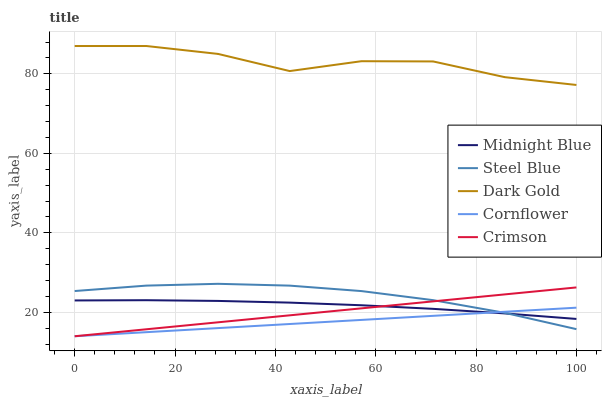Does Cornflower have the minimum area under the curve?
Answer yes or no. Yes. Does Dark Gold have the maximum area under the curve?
Answer yes or no. Yes. Does Dark Gold have the minimum area under the curve?
Answer yes or no. No. Does Cornflower have the maximum area under the curve?
Answer yes or no. No. Is Crimson the smoothest?
Answer yes or no. Yes. Is Dark Gold the roughest?
Answer yes or no. Yes. Is Cornflower the smoothest?
Answer yes or no. No. Is Cornflower the roughest?
Answer yes or no. No. Does Crimson have the lowest value?
Answer yes or no. Yes. Does Dark Gold have the lowest value?
Answer yes or no. No. Does Dark Gold have the highest value?
Answer yes or no. Yes. Does Cornflower have the highest value?
Answer yes or no. No. Is Steel Blue less than Dark Gold?
Answer yes or no. Yes. Is Dark Gold greater than Midnight Blue?
Answer yes or no. Yes. Does Steel Blue intersect Crimson?
Answer yes or no. Yes. Is Steel Blue less than Crimson?
Answer yes or no. No. Is Steel Blue greater than Crimson?
Answer yes or no. No. Does Steel Blue intersect Dark Gold?
Answer yes or no. No. 